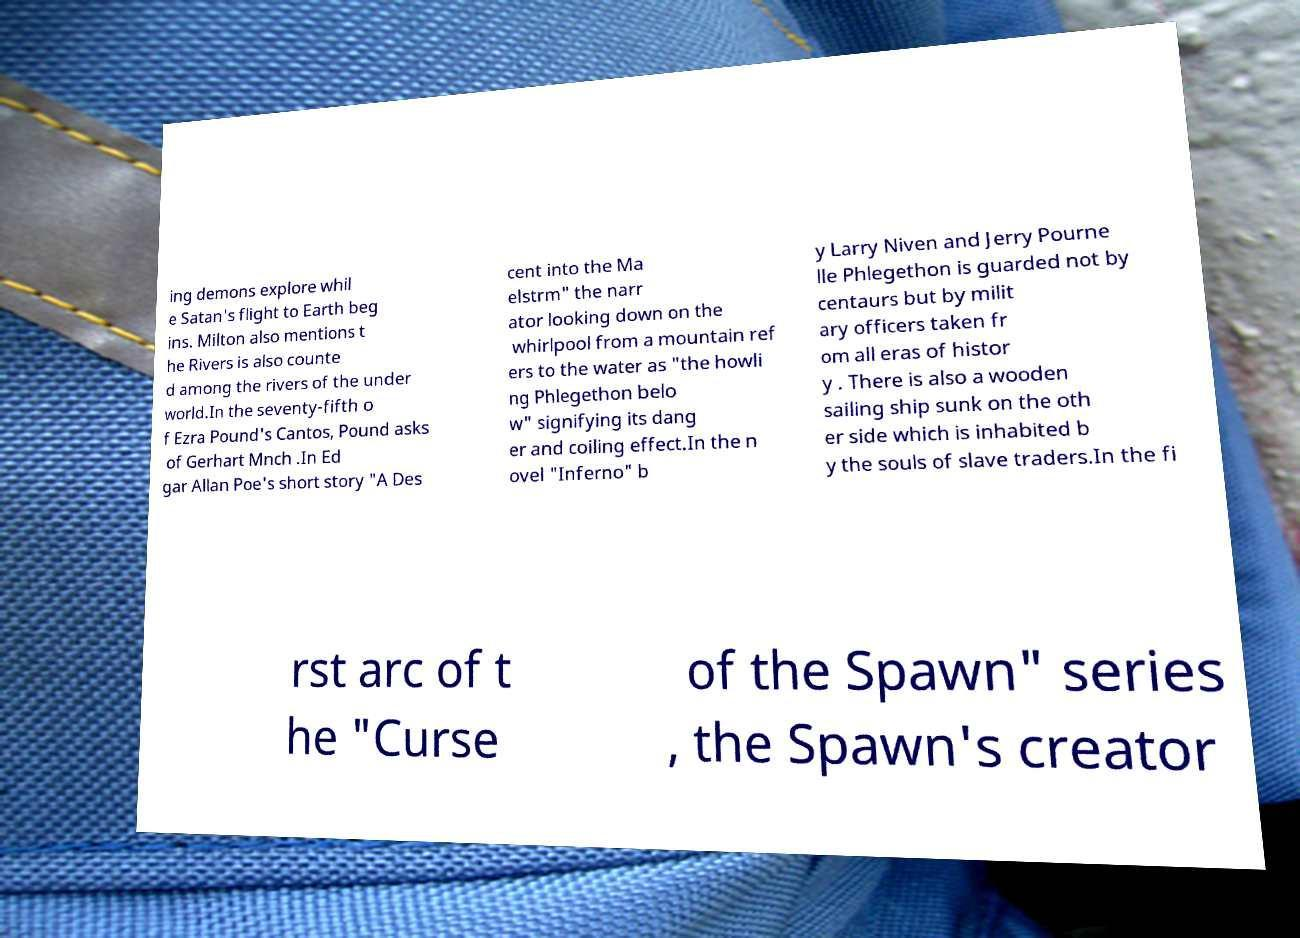Please identify and transcribe the text found in this image. ing demons explore whil e Satan's flight to Earth beg ins. Milton also mentions t he Rivers is also counte d among the rivers of the under world.In the seventy-fifth o f Ezra Pound's Cantos, Pound asks of Gerhart Mnch .In Ed gar Allan Poe's short story "A Des cent into the Ma elstrm" the narr ator looking down on the whirlpool from a mountain ref ers to the water as "the howli ng Phlegethon belo w" signifying its dang er and coiling effect.In the n ovel "Inferno" b y Larry Niven and Jerry Pourne lle Phlegethon is guarded not by centaurs but by milit ary officers taken fr om all eras of histor y . There is also a wooden sailing ship sunk on the oth er side which is inhabited b y the souls of slave traders.In the fi rst arc of t he "Curse of the Spawn" series , the Spawn's creator 